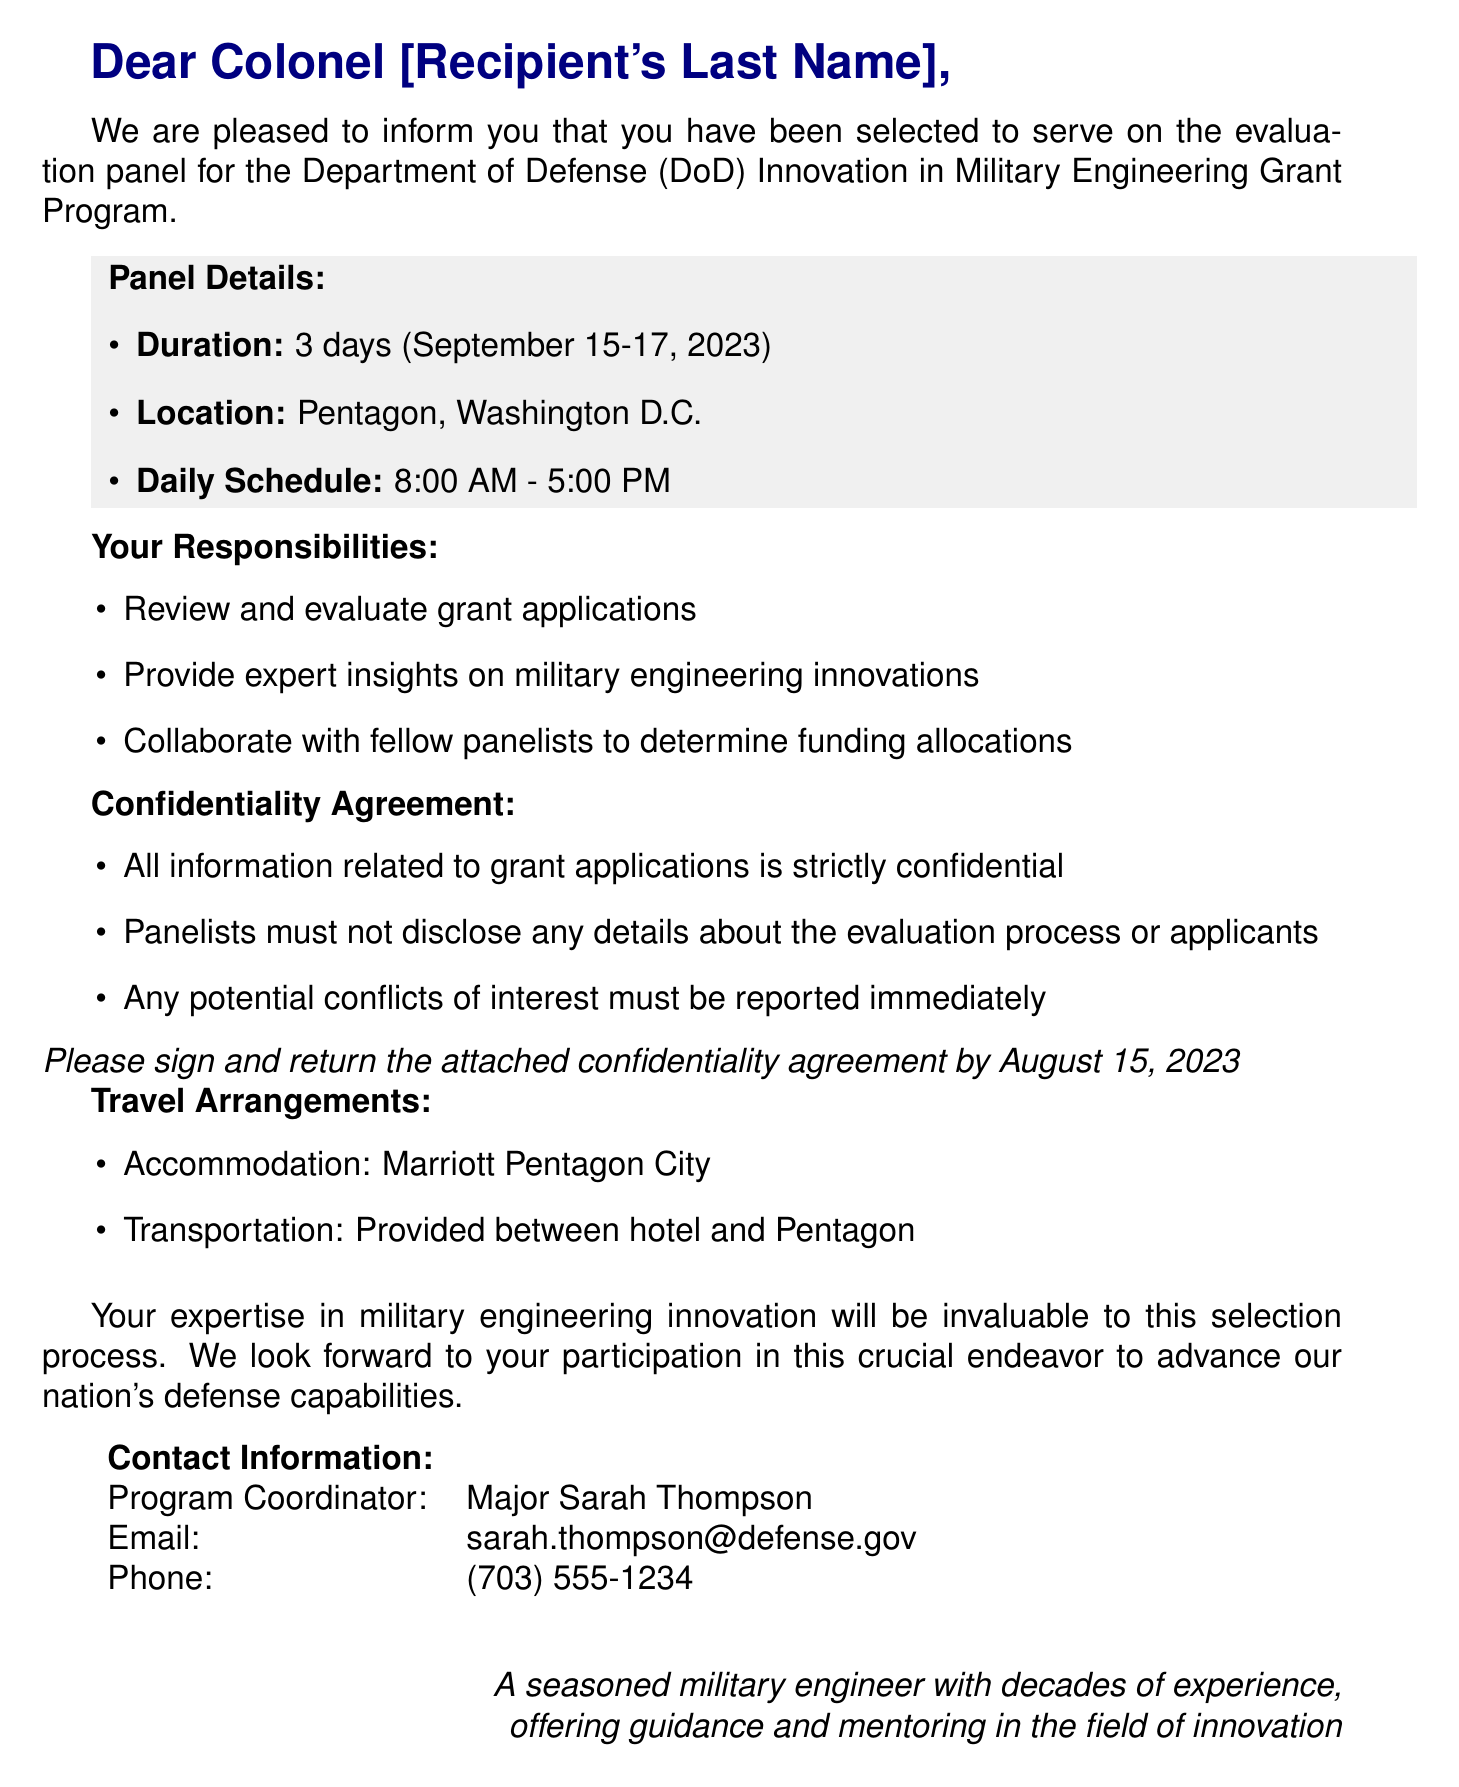What is the panel duration? The panel duration is specified in the document as "3 days".
Answer: 3 days What are the panel dates? The document states the panel dates are "September 15-17, 2023".
Answer: September 15-17, 2023 Who is the program coordinator? The document clearly identifies the program coordinator as "Major Sarah Thompson".
Answer: Major Sarah Thompson What must panelists do regarding confidentiality? The document lists that panelists must not disclose any details about the evaluation process or applicants.
Answer: Not disclose any details Where will accommodations be arranged? The document specifies that accommodations will be made at "Marriott Pentagon City".
Answer: Marriott Pentagon City What is the deadline for the confidentiality agreement? The document indicates that the confidentiality agreement must be signed and returned by "August 15, 2023".
Answer: August 15, 2023 What time does the daily schedule start? The document mentions that the daily schedule starts at "8:00 AM".
Answer: 8:00 AM What should panelists report immediately? The document states that "Any potential conflicts of interest must be reported immediately".
Answer: Potential conflicts of interest 